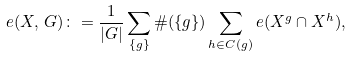<formula> <loc_0><loc_0><loc_500><loc_500>e ( X , \, G ) \colon = \frac { 1 } { | G | } \sum _ { \{ g \} } \# ( \{ g \} ) \sum _ { h \in C ( g ) } e ( X ^ { g } \cap X ^ { h } ) ,</formula> 